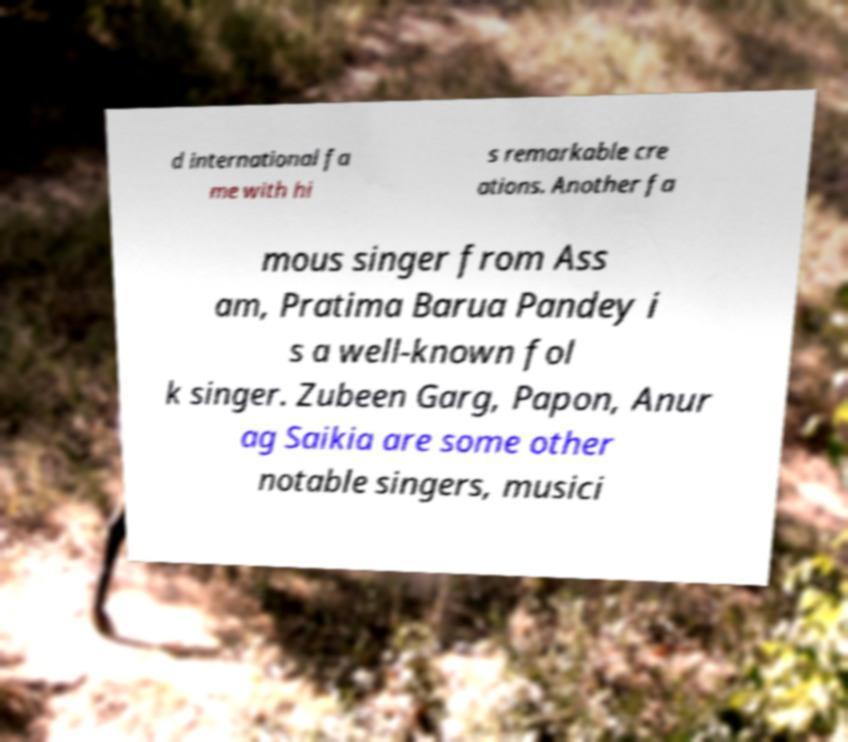I need the written content from this picture converted into text. Can you do that? d international fa me with hi s remarkable cre ations. Another fa mous singer from Ass am, Pratima Barua Pandey i s a well-known fol k singer. Zubeen Garg, Papon, Anur ag Saikia are some other notable singers, musici 